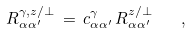<formula> <loc_0><loc_0><loc_500><loc_500>R ^ { \gamma , z / \perp } _ { \alpha \alpha ^ { \prime } } \, = \, c ^ { \gamma } _ { \alpha \alpha ^ { \prime } } \, R ^ { z / \perp } _ { \alpha \alpha ^ { \prime } } \quad ,</formula> 